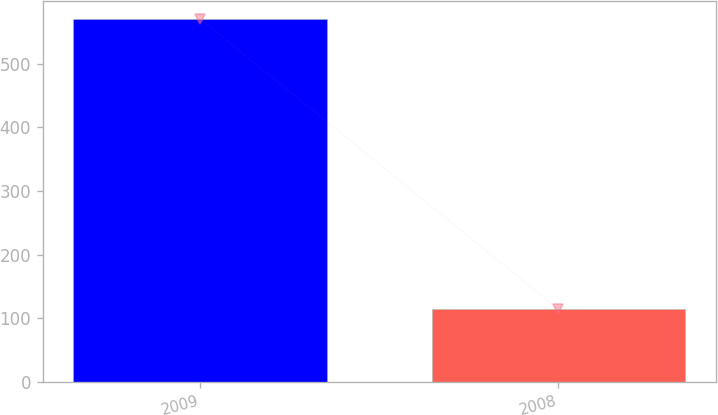<chart> <loc_0><loc_0><loc_500><loc_500><bar_chart><fcel>2009<fcel>2008<nl><fcel>570<fcel>114<nl></chart> 